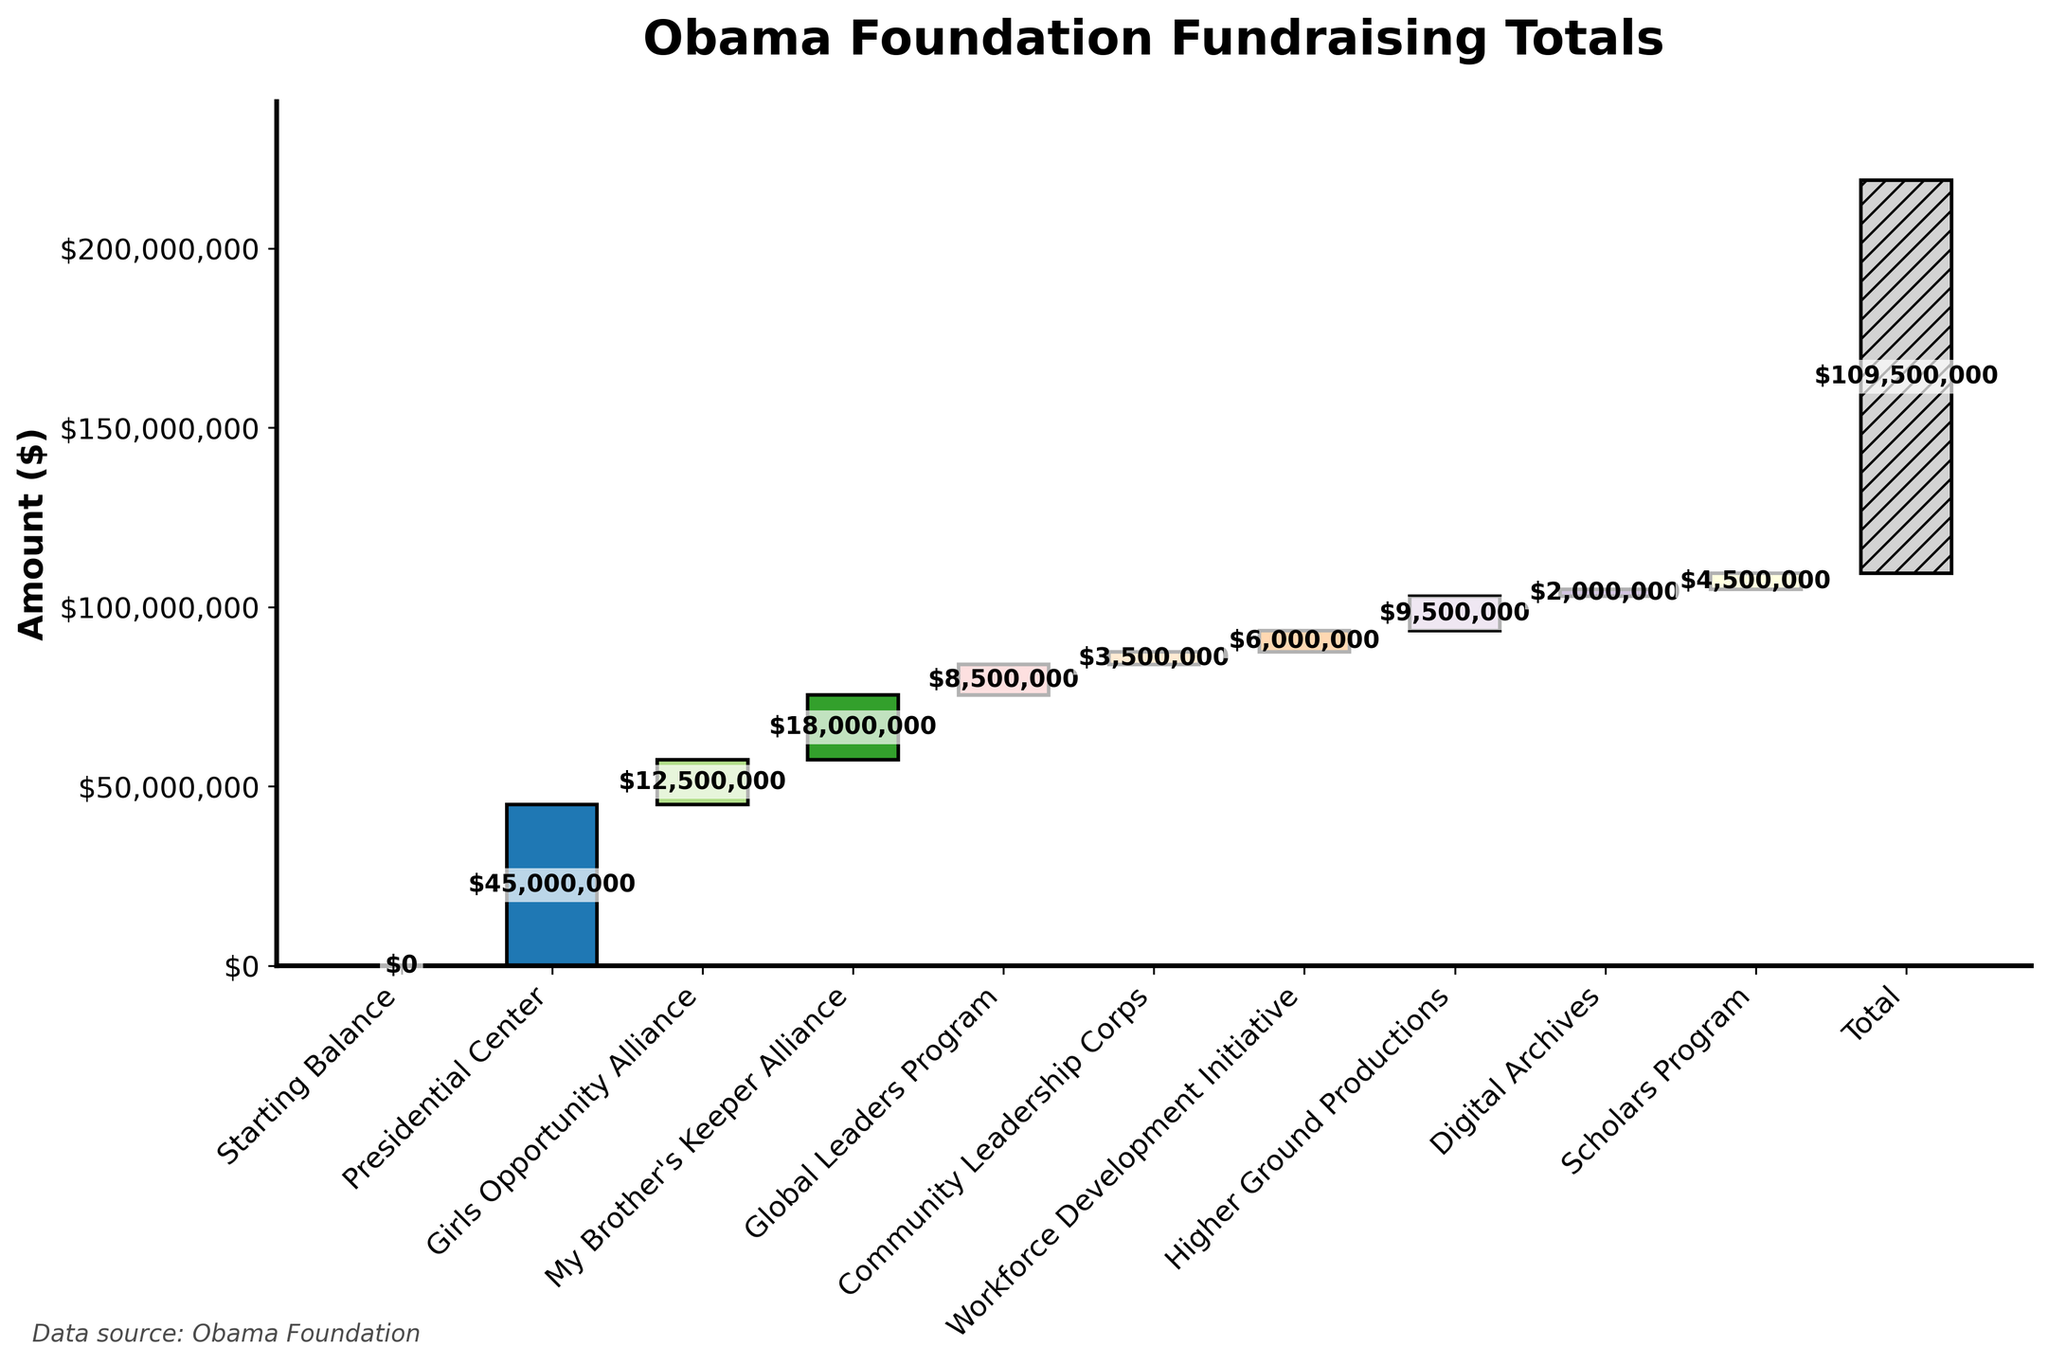What is the title of the chart? The title is usually displayed at the top of the chart, which helps to quickly identify the main purpose or focus of the visualization.
Answer: Obama Foundation Fundraising Totals What does the y-axis represent? The y-axis typically represents the scale of the values being measured in the chart. In this case, it shows monetary amounts.
Answer: Amount ($) Which initiative raised the most funds? Looking at the heights of the bars in the chart, the tallest bar represents the initiative with the highest value.
Answer: Presidential Center What is the total fundraising amount displayed at the end of the chart? The final value shown at the end of a waterfall chart represents the cumulative total of all segments.
Answer: $109,500,000 How much did the “Girls Opportunity Alliance” raise? Refer to the specific bar labeled "Girls Opportunity Alliance" and look at the annotation on the bar to find the value.
Answer: $12,500,000 Which initiative has the smallest contribution? Compare the heights of all bars and identify the shortest one, which indicates the smallest value.
Answer: Digital Archives Which initiatives raised more than $10 million each? Identify the bars with values exceeding $10 million by looking at their annotations or comparing their heights against the $10 million mark on the y-axis.
Answer: Presidential Center, Girls Opportunity Alliance, My Brother's Keeper Alliance 